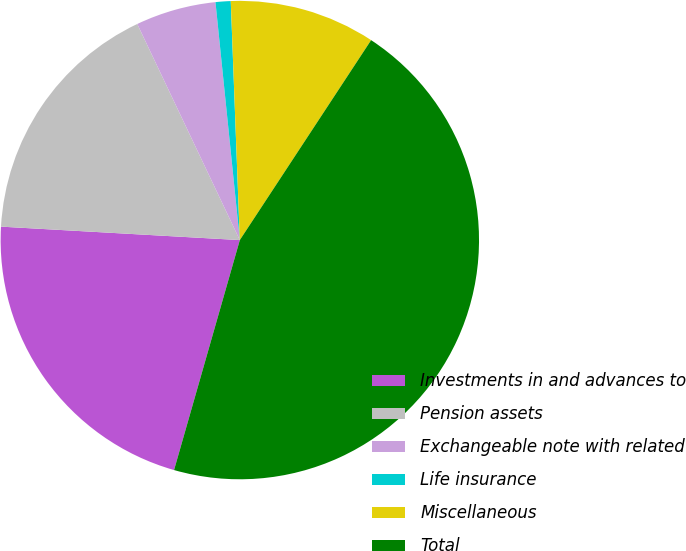<chart> <loc_0><loc_0><loc_500><loc_500><pie_chart><fcel>Investments in and advances to<fcel>Pension assets<fcel>Exchangeable note with related<fcel>Life insurance<fcel>Miscellaneous<fcel>Total<nl><fcel>21.46%<fcel>17.05%<fcel>5.43%<fcel>1.02%<fcel>9.85%<fcel>45.18%<nl></chart> 